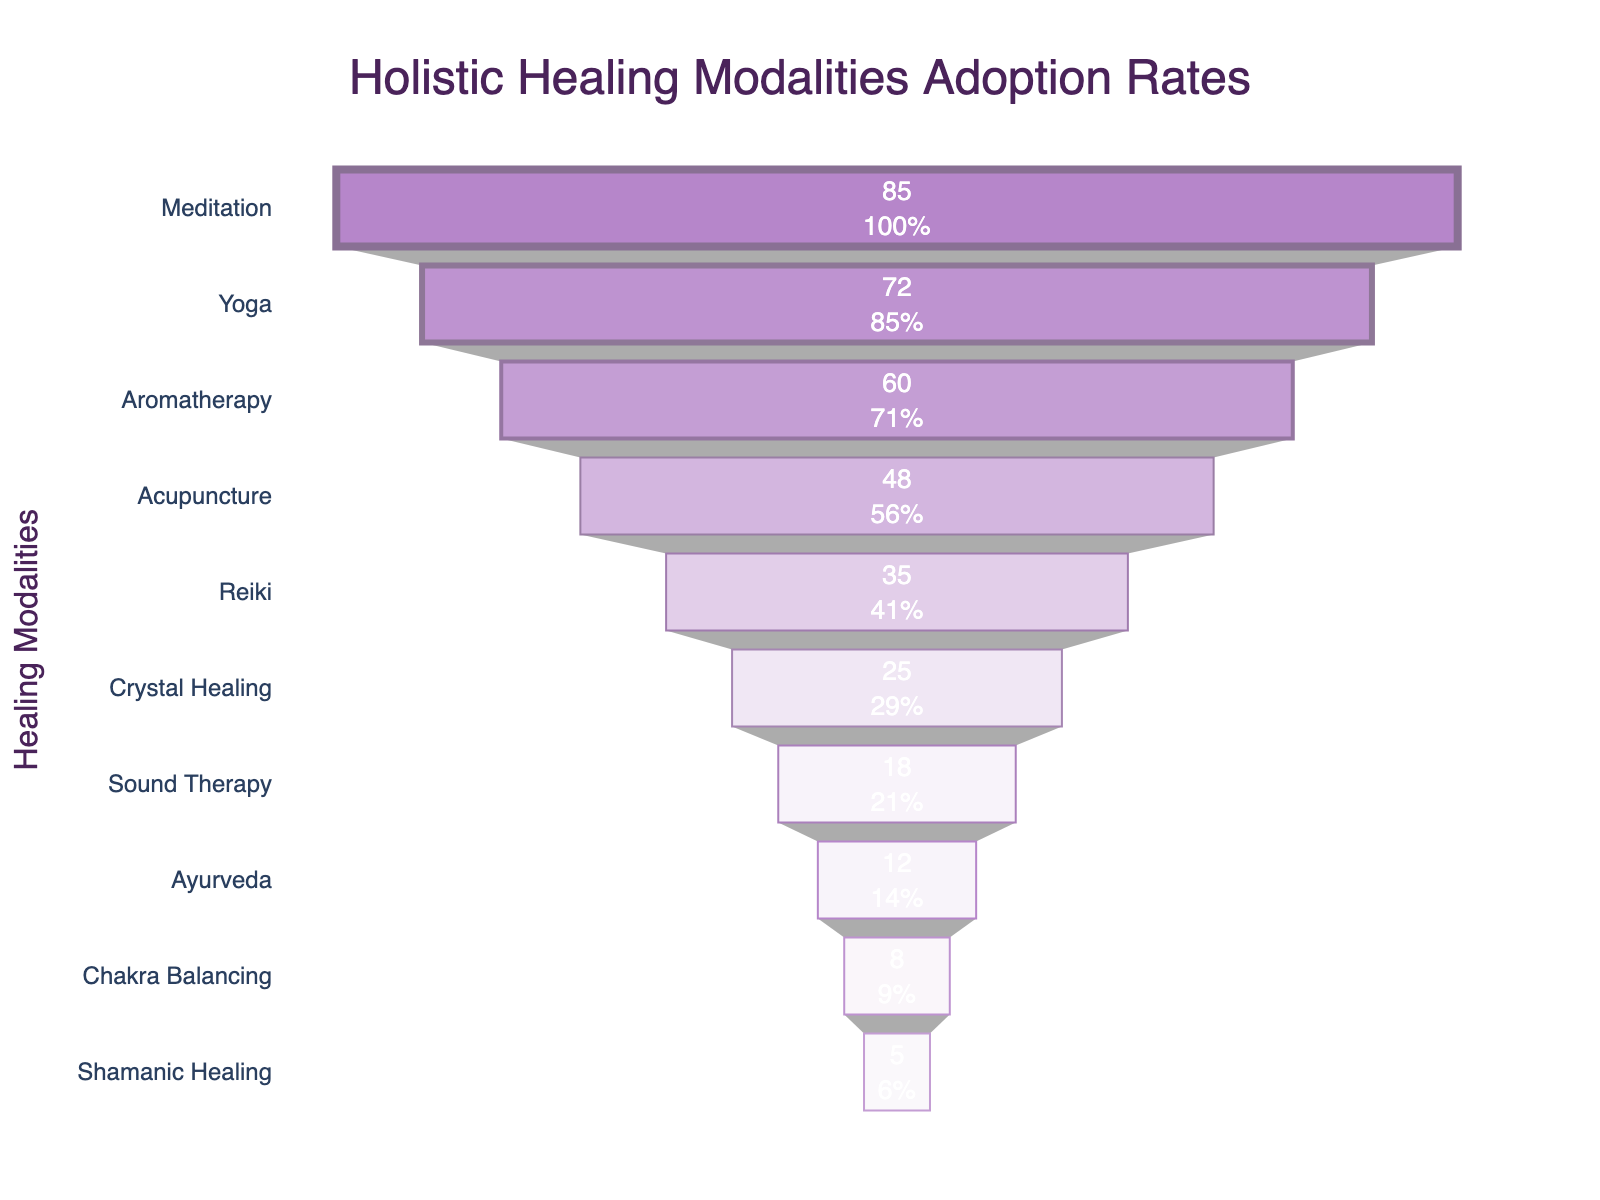What is the title of the chart? The title of the chart is displayed at the top center and it reads "Holistic Healing Modalities Adoption Rates."
Answer: Holistic Healing Modalities Adoption Rates Which healing modality has the highest adoption rate? By looking at the chart, the top-most section of the funnel represents the modality with the highest adoption rate, which is "Meditation" at 85%.
Answer: Meditation What percentage of people adopt Yoga as a healing modality? The funnel chart shows the adoption rate percentages inside each section, and for Yoga, it is 72%.
Answer: 72% What is the difference in adoption rates between the most and the least adopted modalities? The highest adoption rate is for Meditation at 85% and the lowest is for Shamanic Healing at 5%. The difference is calculated as 85 - 5 = 80.
Answer: 80 Which modalities have an adoption rate of less than 50%? By examining the sections below 50% on the chart, the modalities are Acupuncture (48%), Reiki (35%), Crystal Healing (25%), Sound Therapy (18%), Ayurveda (12%), Chakra Balancing (8%), and Shamanic Healing (5%).
Answer: Acupuncture, Reiki, Crystal Healing, Sound Therapy, Ayurveda, Chakra Balancing, Shamanic Healing How many healing modalities are represented in the chart? Counting the different sections in the funnel, there are 10 healing modalities listed: Meditation, Yoga, Aromatherapy, Acupuncture, Reiki, Crystal Healing, Sound Therapy, Ayurveda, Chakra Balancing, and Shamanic Healing.
Answer: 10 What is the second most adopted healing modality? The second section from the top of the funnel shows Yoga with an adoption rate of 72%, making it the second most adopted modality.
Answer: Yoga What is the average adoption rate of the healing modalities listed? Sum all adoption rates (85 + 72 + 60 + 48 + 35 + 25 + 18 + 12 + 8 + 5) = 368 and divide by the number of modalities, which is 10. The average is 368 / 10 = 36.8.
Answer: 36.8 Which healing modality sits right in the middle if the modalities are listed by adoption rate from highest to lowest? Listing the modalities from highest to lowest (Meditation, Yoga, Aromatherapy, Acupuncture, Reiki, Crystal Healing, Sound Therapy, Ayurveda, Chakra Balancing, Shamanic Healing), the one in the middle is Reiki.
Answer: Reiki What is the adoption rate for Crystal Healing? The funnel shows the adoption rate inside each section and for Crystal Healing, it is 25%.
Answer: 25% 